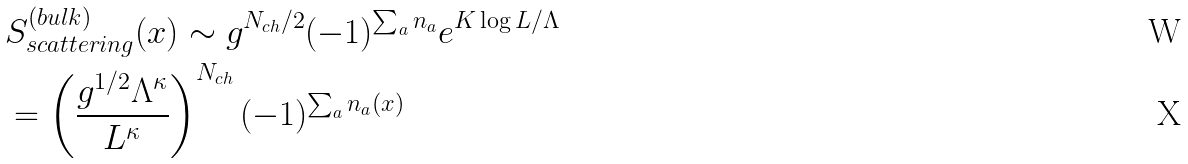Convert formula to latex. <formula><loc_0><loc_0><loc_500><loc_500>& S _ { s c a t t e r i n g } ^ { ( b u l k ) } ( x ) \sim g ^ { N _ { c h } / 2 } ( - 1 ) ^ { \sum _ { a } n _ { a } } e ^ { K \log { L / \Lambda } } \\ & = \left ( \frac { g ^ { 1 / 2 } \Lambda ^ { \kappa } } { L ^ { \kappa } } \right ) ^ { N _ { c h } } ( - 1 ) ^ { \sum _ { a } n _ { a } ( x ) }</formula> 